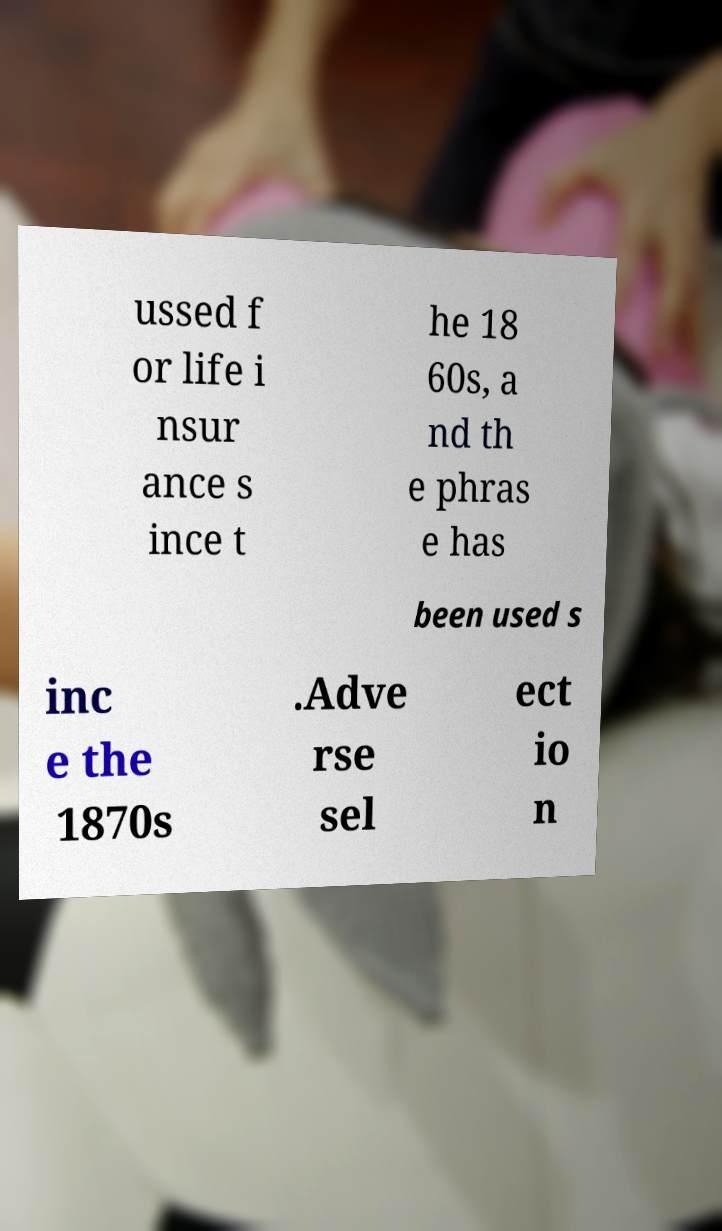Can you accurately transcribe the text from the provided image for me? ussed f or life i nsur ance s ince t he 18 60s, a nd th e phras e has been used s inc e the 1870s .Adve rse sel ect io n 